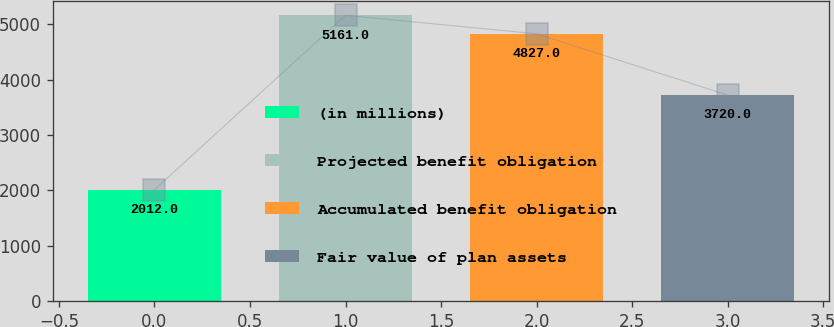Convert chart. <chart><loc_0><loc_0><loc_500><loc_500><bar_chart><fcel>(in millions)<fcel>Projected benefit obligation<fcel>Accumulated benefit obligation<fcel>Fair value of plan assets<nl><fcel>2012<fcel>5161<fcel>4827<fcel>3720<nl></chart> 